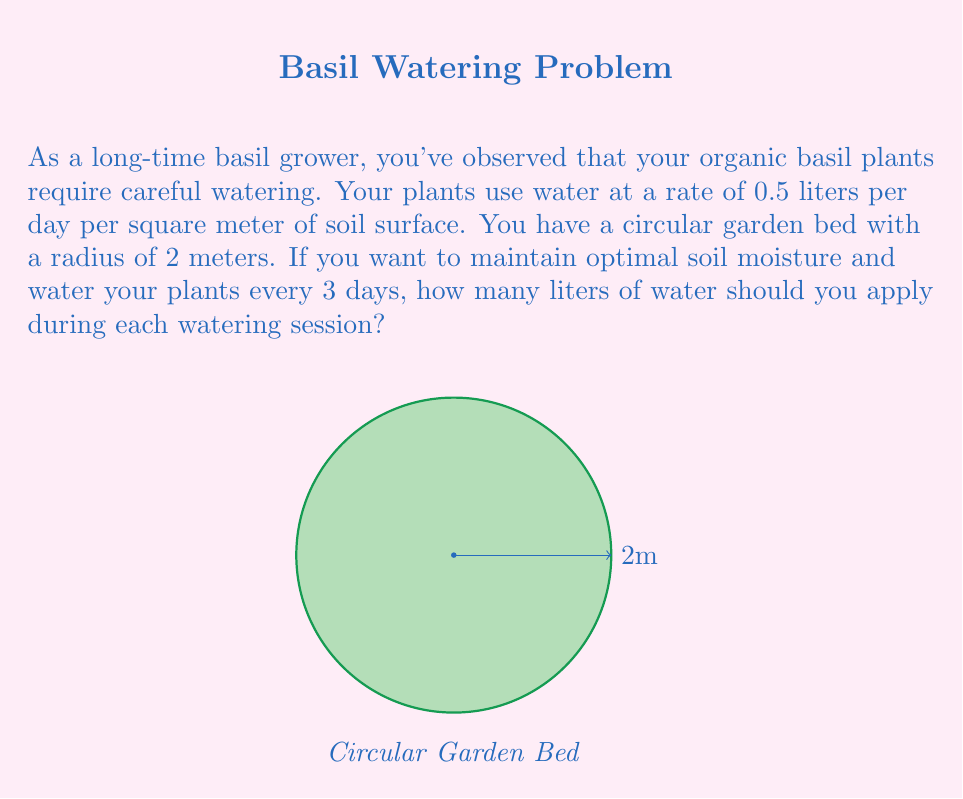Show me your answer to this math problem. Let's break this down step-by-step:

1) First, we need to calculate the area of the circular garden bed:
   $$A = \pi r^2$$
   $$A = \pi \cdot 2^2 = 4\pi \approx 12.57 \text{ m}^2$$

2) Now, we know the water usage rate is 0.5 liters per day per square meter:
   $$\text{Daily water usage} = 0.5 \text{ L/m}^2/\text{day} \cdot 12.57 \text{ m}^2 = 6.285 \text{ L/day}$$

3) We want to water every 3 days, so we need to multiply the daily usage by 3:
   $$\text{Water needed every 3 days} = 6.285 \text{ L/day} \cdot 3 \text{ days} = 18.855 \text{ L}$$

4) Rounding to the nearest whole number for practical purposes:
   $$\text{Water to apply} \approx 19 \text{ L}$$

This amount of water will replenish what the plants have used over the 3-day period, maintaining optimal soil moisture without overwatering.
Answer: 19 L 